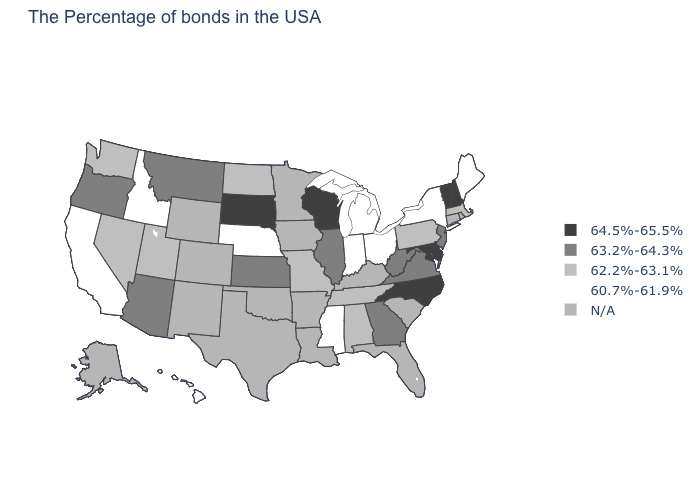How many symbols are there in the legend?
Short answer required. 5. Name the states that have a value in the range 60.7%-61.9%?
Short answer required. Maine, New York, Ohio, Michigan, Indiana, Mississippi, Nebraska, Idaho, California, Hawaii. Is the legend a continuous bar?
Concise answer only. No. What is the value of Michigan?
Be succinct. 60.7%-61.9%. Among the states that border Georgia , which have the lowest value?
Answer briefly. Alabama, Tennessee. Among the states that border Idaho , which have the lowest value?
Write a very short answer. Utah, Nevada, Washington. Which states have the highest value in the USA?
Give a very brief answer. New Hampshire, Vermont, Delaware, Maryland, North Carolina, Wisconsin, South Dakota. What is the value of Wisconsin?
Answer briefly. 64.5%-65.5%. Name the states that have a value in the range 62.2%-63.1%?
Answer briefly. Massachusetts, Pennsylvania, Alabama, Tennessee, Missouri, North Dakota, Utah, Nevada, Washington. What is the value of South Dakota?
Concise answer only. 64.5%-65.5%. What is the value of Pennsylvania?
Give a very brief answer. 62.2%-63.1%. What is the value of New Hampshire?
Be succinct. 64.5%-65.5%. 